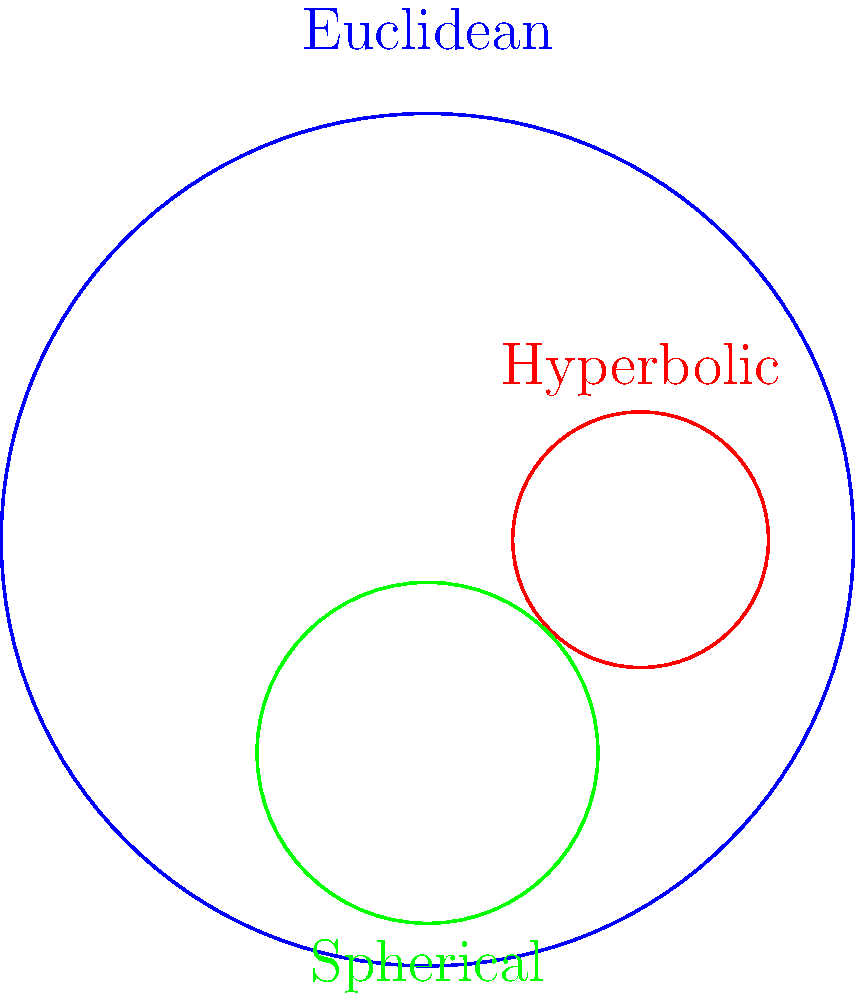As a technology startup founder implementing a visualization tool for non-Euclidean geometries, you need to understand how circles appear in different geometric spaces. In the diagram above, three circles are shown in different geometries. Which circle represents a circle in hyperbolic geometry, and how does its appearance differ from the Euclidean circle? To answer this question, let's analyze the circles in the diagram step-by-step:

1. The blue circle in the center represents a circle in Euclidean geometry. It has a constant curvature and appears as we typically expect a circle to look.

2. The red circle on the right side of the diagram represents a circle in hyperbolic geometry, specifically in the Poincaré disk model. This is the correct answer to the question.

3. The green circle at the bottom represents a circle in spherical geometry, shown as a stereographic projection.

The hyperbolic circle (red) differs from the Euclidean circle (blue) in several ways:

a) Position: It's not centered in the diagram, unlike the Euclidean circle.

b) Size: It appears smaller than the Euclidean circle.

c) Shape: While it still looks circular, in hyperbolic geometry, this circle would have a constant distance from its center in hyperbolic space, not Euclidean space.

d) In the Poincaré disk model, circles that are not centered at the origin of the disk (like this one) appear as Euclidean circles that are not centered at the origin of the disk.

e) As circles in hyperbolic geometry get larger, they appear to approach the boundary of the Poincaré disk, which represents infinity in this model.

Understanding these differences is crucial for accurately representing non-Euclidean geometries in your visualization tool, ensuring that users can correctly interpret the geometric properties of shapes in different spaces.
Answer: The red circle; it's off-center and smaller than the Euclidean circle. 